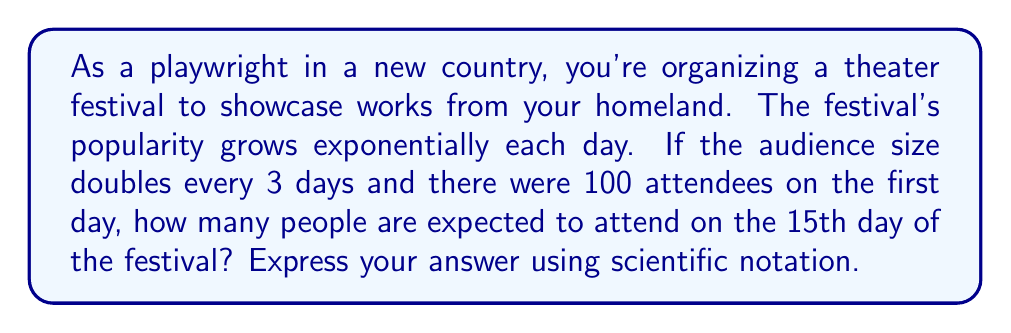Help me with this question. Let's approach this step-by-step:

1) First, we need to identify the exponential growth function. The general form is:

   $$ A(t) = A_0 \cdot b^{t/k} $$

   Where:
   $A(t)$ is the audience size at time $t$
   $A_0$ is the initial audience size
   $b$ is the growth factor
   $k$ is the time it takes for the audience to grow by a factor of $b$

2) In this case:
   $A_0 = 100$ (initial audience)
   $b = 2$ (doubles every 3 days)
   $k = 3$ (days)
   $t = 15$ (we want to know the audience on the 15th day)

3) Plugging these values into our equation:

   $$ A(15) = 100 \cdot 2^{15/3} $$

4) Simplify the exponent:

   $$ A(15) = 100 \cdot 2^5 $$

5) Calculate $2^5$:

   $$ A(15) = 100 \cdot 32 = 3200 $$

6) Express in scientific notation:

   $$ A(15) = 3.2 \times 10^3 $$
Answer: $3.2 \times 10^3$ people 